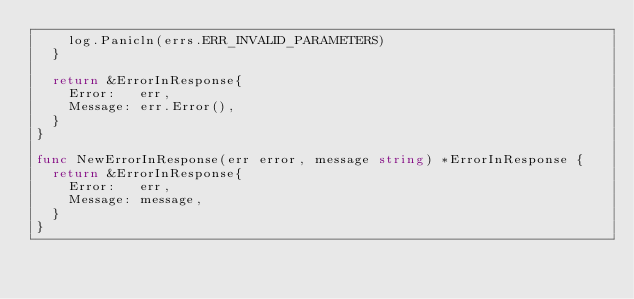Convert code to text. <code><loc_0><loc_0><loc_500><loc_500><_Go_>		log.Panicln(errs.ERR_INVALID_PARAMETERS)
	}

	return &ErrorInResponse{
		Error:   err,
		Message: err.Error(),
	}
}

func NewErrorInResponse(err error, message string) *ErrorInResponse {
	return &ErrorInResponse{
		Error:   err,
		Message: message,
	}
}
</code> 